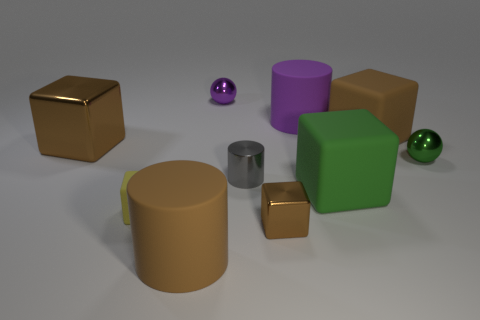How many brown blocks must be subtracted to get 1 brown blocks? 2 Subtract all shiny cubes. How many cubes are left? 3 Subtract all yellow cubes. How many cubes are left? 4 Subtract 1 cylinders. How many cylinders are left? 2 Subtract all cylinders. How many objects are left? 7 Subtract 0 cyan cylinders. How many objects are left? 10 Subtract all brown cylinders. Subtract all yellow blocks. How many cylinders are left? 2 Subtract all cyan cylinders. How many purple balls are left? 1 Subtract all large blue matte cylinders. Subtract all tiny gray shiny things. How many objects are left? 9 Add 2 big brown matte cylinders. How many big brown matte cylinders are left? 3 